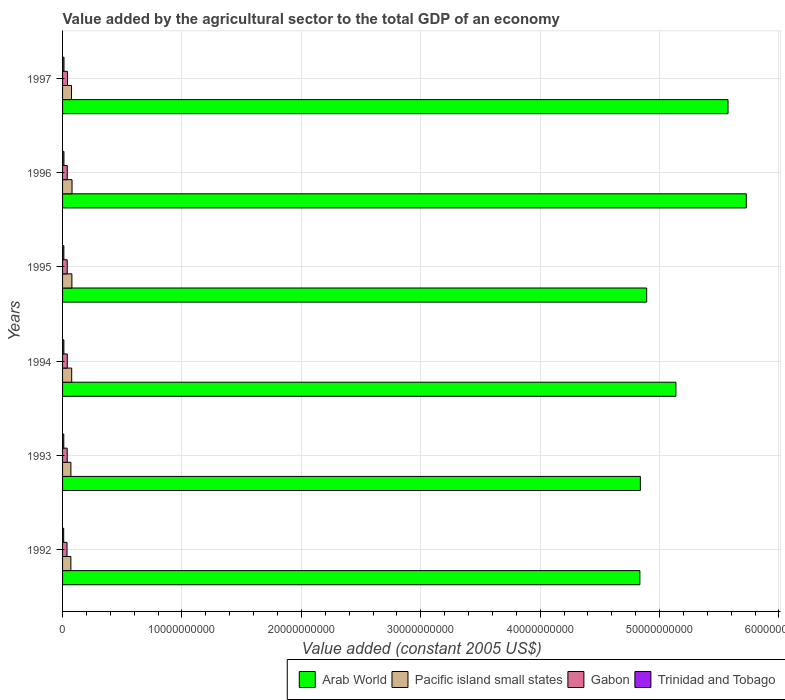How many different coloured bars are there?
Your answer should be very brief. 4. Are the number of bars on each tick of the Y-axis equal?
Keep it short and to the point. Yes. How many bars are there on the 3rd tick from the top?
Provide a succinct answer. 4. How many bars are there on the 3rd tick from the bottom?
Provide a short and direct response. 4. What is the value added by the agricultural sector in Trinidad and Tobago in 1997?
Provide a short and direct response. 1.20e+08. Across all years, what is the maximum value added by the agricultural sector in Arab World?
Keep it short and to the point. 5.73e+1. Across all years, what is the minimum value added by the agricultural sector in Trinidad and Tobago?
Offer a terse response. 9.41e+07. In which year was the value added by the agricultural sector in Pacific island small states maximum?
Your response must be concise. 1996. In which year was the value added by the agricultural sector in Trinidad and Tobago minimum?
Keep it short and to the point. 1992. What is the total value added by the agricultural sector in Pacific island small states in the graph?
Keep it short and to the point. 4.48e+09. What is the difference between the value added by the agricultural sector in Arab World in 1992 and that in 1994?
Your answer should be compact. -3.02e+09. What is the difference between the value added by the agricultural sector in Trinidad and Tobago in 1992 and the value added by the agricultural sector in Arab World in 1994?
Provide a succinct answer. -5.13e+1. What is the average value added by the agricultural sector in Arab World per year?
Provide a short and direct response. 5.17e+1. In the year 1996, what is the difference between the value added by the agricultural sector in Gabon and value added by the agricultural sector in Arab World?
Keep it short and to the point. -5.69e+1. What is the ratio of the value added by the agricultural sector in Gabon in 1992 to that in 1994?
Offer a very short reply. 0.94. Is the difference between the value added by the agricultural sector in Gabon in 1993 and 1996 greater than the difference between the value added by the agricultural sector in Arab World in 1993 and 1996?
Provide a short and direct response. Yes. What is the difference between the highest and the second highest value added by the agricultural sector in Gabon?
Your answer should be compact. 1.54e+07. What is the difference between the highest and the lowest value added by the agricultural sector in Gabon?
Ensure brevity in your answer.  3.72e+07. Is the sum of the value added by the agricultural sector in Trinidad and Tobago in 1994 and 1996 greater than the maximum value added by the agricultural sector in Arab World across all years?
Keep it short and to the point. No. Is it the case that in every year, the sum of the value added by the agricultural sector in Pacific island small states and value added by the agricultural sector in Trinidad and Tobago is greater than the sum of value added by the agricultural sector in Gabon and value added by the agricultural sector in Arab World?
Make the answer very short. No. What does the 2nd bar from the top in 1995 represents?
Your answer should be very brief. Gabon. What does the 3rd bar from the bottom in 1995 represents?
Offer a very short reply. Gabon. What is the difference between two consecutive major ticks on the X-axis?
Provide a succinct answer. 1.00e+1. Does the graph contain any zero values?
Your answer should be very brief. No. How many legend labels are there?
Provide a succinct answer. 4. What is the title of the graph?
Keep it short and to the point. Value added by the agricultural sector to the total GDP of an economy. Does "Korea (Republic)" appear as one of the legend labels in the graph?
Offer a terse response. No. What is the label or title of the X-axis?
Offer a terse response. Value added (constant 2005 US$). What is the Value added (constant 2005 US$) in Arab World in 1992?
Keep it short and to the point. 4.84e+1. What is the Value added (constant 2005 US$) of Pacific island small states in 1992?
Provide a short and direct response. 6.95e+08. What is the Value added (constant 2005 US$) in Gabon in 1992?
Provide a short and direct response. 3.73e+08. What is the Value added (constant 2005 US$) in Trinidad and Tobago in 1992?
Provide a succinct answer. 9.41e+07. What is the Value added (constant 2005 US$) of Arab World in 1993?
Provide a short and direct response. 4.84e+1. What is the Value added (constant 2005 US$) in Pacific island small states in 1993?
Your response must be concise. 6.99e+08. What is the Value added (constant 2005 US$) in Gabon in 1993?
Your answer should be compact. 3.89e+08. What is the Value added (constant 2005 US$) in Trinidad and Tobago in 1993?
Your response must be concise. 1.02e+08. What is the Value added (constant 2005 US$) of Arab World in 1994?
Your answer should be compact. 5.14e+1. What is the Value added (constant 2005 US$) of Pacific island small states in 1994?
Offer a terse response. 7.65e+08. What is the Value added (constant 2005 US$) of Gabon in 1994?
Give a very brief answer. 3.95e+08. What is the Value added (constant 2005 US$) in Trinidad and Tobago in 1994?
Your answer should be compact. 1.10e+08. What is the Value added (constant 2005 US$) of Arab World in 1995?
Keep it short and to the point. 4.89e+1. What is the Value added (constant 2005 US$) in Pacific island small states in 1995?
Keep it short and to the point. 7.81e+08. What is the Value added (constant 2005 US$) of Gabon in 1995?
Offer a very short reply. 3.90e+08. What is the Value added (constant 2005 US$) of Trinidad and Tobago in 1995?
Offer a terse response. 1.08e+08. What is the Value added (constant 2005 US$) in Arab World in 1996?
Ensure brevity in your answer.  5.73e+1. What is the Value added (constant 2005 US$) in Pacific island small states in 1996?
Ensure brevity in your answer.  7.92e+08. What is the Value added (constant 2005 US$) in Gabon in 1996?
Give a very brief answer. 3.93e+08. What is the Value added (constant 2005 US$) in Trinidad and Tobago in 1996?
Provide a short and direct response. 1.17e+08. What is the Value added (constant 2005 US$) in Arab World in 1997?
Offer a very short reply. 5.57e+1. What is the Value added (constant 2005 US$) of Pacific island small states in 1997?
Provide a short and direct response. 7.49e+08. What is the Value added (constant 2005 US$) in Gabon in 1997?
Your response must be concise. 4.10e+08. What is the Value added (constant 2005 US$) in Trinidad and Tobago in 1997?
Keep it short and to the point. 1.20e+08. Across all years, what is the maximum Value added (constant 2005 US$) of Arab World?
Your response must be concise. 5.73e+1. Across all years, what is the maximum Value added (constant 2005 US$) in Pacific island small states?
Provide a succinct answer. 7.92e+08. Across all years, what is the maximum Value added (constant 2005 US$) of Gabon?
Make the answer very short. 4.10e+08. Across all years, what is the maximum Value added (constant 2005 US$) of Trinidad and Tobago?
Your answer should be very brief. 1.20e+08. Across all years, what is the minimum Value added (constant 2005 US$) in Arab World?
Make the answer very short. 4.84e+1. Across all years, what is the minimum Value added (constant 2005 US$) in Pacific island small states?
Provide a succinct answer. 6.95e+08. Across all years, what is the minimum Value added (constant 2005 US$) in Gabon?
Provide a succinct answer. 3.73e+08. Across all years, what is the minimum Value added (constant 2005 US$) of Trinidad and Tobago?
Offer a very short reply. 9.41e+07. What is the total Value added (constant 2005 US$) of Arab World in the graph?
Provide a short and direct response. 3.10e+11. What is the total Value added (constant 2005 US$) of Pacific island small states in the graph?
Provide a succinct answer. 4.48e+09. What is the total Value added (constant 2005 US$) of Gabon in the graph?
Your answer should be very brief. 2.35e+09. What is the total Value added (constant 2005 US$) of Trinidad and Tobago in the graph?
Make the answer very short. 6.51e+08. What is the difference between the Value added (constant 2005 US$) of Arab World in 1992 and that in 1993?
Your response must be concise. -4.10e+07. What is the difference between the Value added (constant 2005 US$) in Pacific island small states in 1992 and that in 1993?
Ensure brevity in your answer.  -3.62e+06. What is the difference between the Value added (constant 2005 US$) of Gabon in 1992 and that in 1993?
Make the answer very short. -1.60e+07. What is the difference between the Value added (constant 2005 US$) in Trinidad and Tobago in 1992 and that in 1993?
Offer a terse response. -7.92e+06. What is the difference between the Value added (constant 2005 US$) in Arab World in 1992 and that in 1994?
Provide a short and direct response. -3.02e+09. What is the difference between the Value added (constant 2005 US$) in Pacific island small states in 1992 and that in 1994?
Make the answer very short. -6.95e+07. What is the difference between the Value added (constant 2005 US$) in Gabon in 1992 and that in 1994?
Your answer should be compact. -2.18e+07. What is the difference between the Value added (constant 2005 US$) of Trinidad and Tobago in 1992 and that in 1994?
Offer a terse response. -1.58e+07. What is the difference between the Value added (constant 2005 US$) in Arab World in 1992 and that in 1995?
Offer a terse response. -5.71e+08. What is the difference between the Value added (constant 2005 US$) of Pacific island small states in 1992 and that in 1995?
Offer a very short reply. -8.57e+07. What is the difference between the Value added (constant 2005 US$) of Gabon in 1992 and that in 1995?
Offer a very short reply. -1.66e+07. What is the difference between the Value added (constant 2005 US$) of Trinidad and Tobago in 1992 and that in 1995?
Provide a succinct answer. -1.44e+07. What is the difference between the Value added (constant 2005 US$) in Arab World in 1992 and that in 1996?
Ensure brevity in your answer.  -8.91e+09. What is the difference between the Value added (constant 2005 US$) of Pacific island small states in 1992 and that in 1996?
Your answer should be compact. -9.69e+07. What is the difference between the Value added (constant 2005 US$) in Gabon in 1992 and that in 1996?
Offer a terse response. -2.03e+07. What is the difference between the Value added (constant 2005 US$) in Trinidad and Tobago in 1992 and that in 1996?
Your response must be concise. -2.25e+07. What is the difference between the Value added (constant 2005 US$) in Arab World in 1992 and that in 1997?
Your answer should be compact. -7.38e+09. What is the difference between the Value added (constant 2005 US$) in Pacific island small states in 1992 and that in 1997?
Make the answer very short. -5.40e+07. What is the difference between the Value added (constant 2005 US$) in Gabon in 1992 and that in 1997?
Your answer should be compact. -3.72e+07. What is the difference between the Value added (constant 2005 US$) in Trinidad and Tobago in 1992 and that in 1997?
Make the answer very short. -2.61e+07. What is the difference between the Value added (constant 2005 US$) in Arab World in 1993 and that in 1994?
Provide a short and direct response. -2.98e+09. What is the difference between the Value added (constant 2005 US$) in Pacific island small states in 1993 and that in 1994?
Offer a terse response. -6.59e+07. What is the difference between the Value added (constant 2005 US$) of Gabon in 1993 and that in 1994?
Keep it short and to the point. -5.75e+06. What is the difference between the Value added (constant 2005 US$) in Trinidad and Tobago in 1993 and that in 1994?
Provide a short and direct response. -7.84e+06. What is the difference between the Value added (constant 2005 US$) of Arab World in 1993 and that in 1995?
Offer a terse response. -5.30e+08. What is the difference between the Value added (constant 2005 US$) of Pacific island small states in 1993 and that in 1995?
Offer a terse response. -8.21e+07. What is the difference between the Value added (constant 2005 US$) in Gabon in 1993 and that in 1995?
Offer a very short reply. -6.05e+05. What is the difference between the Value added (constant 2005 US$) in Trinidad and Tobago in 1993 and that in 1995?
Your answer should be very brief. -6.44e+06. What is the difference between the Value added (constant 2005 US$) of Arab World in 1993 and that in 1996?
Provide a short and direct response. -8.87e+09. What is the difference between the Value added (constant 2005 US$) of Pacific island small states in 1993 and that in 1996?
Your answer should be very brief. -9.33e+07. What is the difference between the Value added (constant 2005 US$) in Gabon in 1993 and that in 1996?
Your answer should be very brief. -4.24e+06. What is the difference between the Value added (constant 2005 US$) in Trinidad and Tobago in 1993 and that in 1996?
Ensure brevity in your answer.  -1.46e+07. What is the difference between the Value added (constant 2005 US$) of Arab World in 1993 and that in 1997?
Your answer should be very brief. -7.34e+09. What is the difference between the Value added (constant 2005 US$) in Pacific island small states in 1993 and that in 1997?
Offer a terse response. -5.04e+07. What is the difference between the Value added (constant 2005 US$) in Gabon in 1993 and that in 1997?
Offer a terse response. -2.12e+07. What is the difference between the Value added (constant 2005 US$) in Trinidad and Tobago in 1993 and that in 1997?
Keep it short and to the point. -1.82e+07. What is the difference between the Value added (constant 2005 US$) of Arab World in 1994 and that in 1995?
Provide a succinct answer. 2.45e+09. What is the difference between the Value added (constant 2005 US$) in Pacific island small states in 1994 and that in 1995?
Your answer should be very brief. -1.62e+07. What is the difference between the Value added (constant 2005 US$) of Gabon in 1994 and that in 1995?
Provide a succinct answer. 5.15e+06. What is the difference between the Value added (constant 2005 US$) of Trinidad and Tobago in 1994 and that in 1995?
Offer a very short reply. 1.41e+06. What is the difference between the Value added (constant 2005 US$) of Arab World in 1994 and that in 1996?
Your answer should be very brief. -5.89e+09. What is the difference between the Value added (constant 2005 US$) of Pacific island small states in 1994 and that in 1996?
Make the answer very short. -2.74e+07. What is the difference between the Value added (constant 2005 US$) in Gabon in 1994 and that in 1996?
Keep it short and to the point. 1.51e+06. What is the difference between the Value added (constant 2005 US$) in Trinidad and Tobago in 1994 and that in 1996?
Your response must be concise. -6.77e+06. What is the difference between the Value added (constant 2005 US$) of Arab World in 1994 and that in 1997?
Ensure brevity in your answer.  -4.36e+09. What is the difference between the Value added (constant 2005 US$) of Pacific island small states in 1994 and that in 1997?
Your response must be concise. 1.55e+07. What is the difference between the Value added (constant 2005 US$) in Gabon in 1994 and that in 1997?
Give a very brief answer. -1.54e+07. What is the difference between the Value added (constant 2005 US$) in Trinidad and Tobago in 1994 and that in 1997?
Offer a very short reply. -1.04e+07. What is the difference between the Value added (constant 2005 US$) of Arab World in 1995 and that in 1996?
Keep it short and to the point. -8.34e+09. What is the difference between the Value added (constant 2005 US$) in Pacific island small states in 1995 and that in 1996?
Offer a terse response. -1.12e+07. What is the difference between the Value added (constant 2005 US$) of Gabon in 1995 and that in 1996?
Keep it short and to the point. -3.63e+06. What is the difference between the Value added (constant 2005 US$) in Trinidad and Tobago in 1995 and that in 1996?
Your answer should be compact. -8.18e+06. What is the difference between the Value added (constant 2005 US$) in Arab World in 1995 and that in 1997?
Provide a short and direct response. -6.81e+09. What is the difference between the Value added (constant 2005 US$) in Pacific island small states in 1995 and that in 1997?
Make the answer very short. 3.17e+07. What is the difference between the Value added (constant 2005 US$) in Gabon in 1995 and that in 1997?
Offer a terse response. -2.06e+07. What is the difference between the Value added (constant 2005 US$) in Trinidad and Tobago in 1995 and that in 1997?
Your response must be concise. -1.18e+07. What is the difference between the Value added (constant 2005 US$) in Arab World in 1996 and that in 1997?
Make the answer very short. 1.53e+09. What is the difference between the Value added (constant 2005 US$) in Pacific island small states in 1996 and that in 1997?
Offer a terse response. 4.29e+07. What is the difference between the Value added (constant 2005 US$) of Gabon in 1996 and that in 1997?
Ensure brevity in your answer.  -1.69e+07. What is the difference between the Value added (constant 2005 US$) of Trinidad and Tobago in 1996 and that in 1997?
Your answer should be compact. -3.61e+06. What is the difference between the Value added (constant 2005 US$) of Arab World in 1992 and the Value added (constant 2005 US$) of Pacific island small states in 1993?
Give a very brief answer. 4.77e+1. What is the difference between the Value added (constant 2005 US$) of Arab World in 1992 and the Value added (constant 2005 US$) of Gabon in 1993?
Provide a succinct answer. 4.80e+1. What is the difference between the Value added (constant 2005 US$) of Arab World in 1992 and the Value added (constant 2005 US$) of Trinidad and Tobago in 1993?
Ensure brevity in your answer.  4.82e+1. What is the difference between the Value added (constant 2005 US$) of Pacific island small states in 1992 and the Value added (constant 2005 US$) of Gabon in 1993?
Keep it short and to the point. 3.07e+08. What is the difference between the Value added (constant 2005 US$) of Pacific island small states in 1992 and the Value added (constant 2005 US$) of Trinidad and Tobago in 1993?
Offer a very short reply. 5.93e+08. What is the difference between the Value added (constant 2005 US$) in Gabon in 1992 and the Value added (constant 2005 US$) in Trinidad and Tobago in 1993?
Ensure brevity in your answer.  2.71e+08. What is the difference between the Value added (constant 2005 US$) of Arab World in 1992 and the Value added (constant 2005 US$) of Pacific island small states in 1994?
Offer a terse response. 4.76e+1. What is the difference between the Value added (constant 2005 US$) of Arab World in 1992 and the Value added (constant 2005 US$) of Gabon in 1994?
Your answer should be very brief. 4.80e+1. What is the difference between the Value added (constant 2005 US$) in Arab World in 1992 and the Value added (constant 2005 US$) in Trinidad and Tobago in 1994?
Your response must be concise. 4.82e+1. What is the difference between the Value added (constant 2005 US$) in Pacific island small states in 1992 and the Value added (constant 2005 US$) in Gabon in 1994?
Your response must be concise. 3.01e+08. What is the difference between the Value added (constant 2005 US$) of Pacific island small states in 1992 and the Value added (constant 2005 US$) of Trinidad and Tobago in 1994?
Offer a very short reply. 5.86e+08. What is the difference between the Value added (constant 2005 US$) of Gabon in 1992 and the Value added (constant 2005 US$) of Trinidad and Tobago in 1994?
Offer a terse response. 2.63e+08. What is the difference between the Value added (constant 2005 US$) in Arab World in 1992 and the Value added (constant 2005 US$) in Pacific island small states in 1995?
Offer a very short reply. 4.76e+1. What is the difference between the Value added (constant 2005 US$) of Arab World in 1992 and the Value added (constant 2005 US$) of Gabon in 1995?
Offer a terse response. 4.80e+1. What is the difference between the Value added (constant 2005 US$) of Arab World in 1992 and the Value added (constant 2005 US$) of Trinidad and Tobago in 1995?
Ensure brevity in your answer.  4.82e+1. What is the difference between the Value added (constant 2005 US$) of Pacific island small states in 1992 and the Value added (constant 2005 US$) of Gabon in 1995?
Make the answer very short. 3.06e+08. What is the difference between the Value added (constant 2005 US$) of Pacific island small states in 1992 and the Value added (constant 2005 US$) of Trinidad and Tobago in 1995?
Your response must be concise. 5.87e+08. What is the difference between the Value added (constant 2005 US$) of Gabon in 1992 and the Value added (constant 2005 US$) of Trinidad and Tobago in 1995?
Provide a short and direct response. 2.64e+08. What is the difference between the Value added (constant 2005 US$) of Arab World in 1992 and the Value added (constant 2005 US$) of Pacific island small states in 1996?
Your response must be concise. 4.76e+1. What is the difference between the Value added (constant 2005 US$) in Arab World in 1992 and the Value added (constant 2005 US$) in Gabon in 1996?
Ensure brevity in your answer.  4.80e+1. What is the difference between the Value added (constant 2005 US$) in Arab World in 1992 and the Value added (constant 2005 US$) in Trinidad and Tobago in 1996?
Your answer should be compact. 4.82e+1. What is the difference between the Value added (constant 2005 US$) in Pacific island small states in 1992 and the Value added (constant 2005 US$) in Gabon in 1996?
Your response must be concise. 3.02e+08. What is the difference between the Value added (constant 2005 US$) of Pacific island small states in 1992 and the Value added (constant 2005 US$) of Trinidad and Tobago in 1996?
Provide a short and direct response. 5.79e+08. What is the difference between the Value added (constant 2005 US$) in Gabon in 1992 and the Value added (constant 2005 US$) in Trinidad and Tobago in 1996?
Offer a very short reply. 2.56e+08. What is the difference between the Value added (constant 2005 US$) in Arab World in 1992 and the Value added (constant 2005 US$) in Pacific island small states in 1997?
Offer a very short reply. 4.76e+1. What is the difference between the Value added (constant 2005 US$) of Arab World in 1992 and the Value added (constant 2005 US$) of Gabon in 1997?
Keep it short and to the point. 4.79e+1. What is the difference between the Value added (constant 2005 US$) in Arab World in 1992 and the Value added (constant 2005 US$) in Trinidad and Tobago in 1997?
Your answer should be very brief. 4.82e+1. What is the difference between the Value added (constant 2005 US$) in Pacific island small states in 1992 and the Value added (constant 2005 US$) in Gabon in 1997?
Provide a short and direct response. 2.85e+08. What is the difference between the Value added (constant 2005 US$) of Pacific island small states in 1992 and the Value added (constant 2005 US$) of Trinidad and Tobago in 1997?
Provide a short and direct response. 5.75e+08. What is the difference between the Value added (constant 2005 US$) of Gabon in 1992 and the Value added (constant 2005 US$) of Trinidad and Tobago in 1997?
Your answer should be very brief. 2.53e+08. What is the difference between the Value added (constant 2005 US$) in Arab World in 1993 and the Value added (constant 2005 US$) in Pacific island small states in 1994?
Give a very brief answer. 4.76e+1. What is the difference between the Value added (constant 2005 US$) in Arab World in 1993 and the Value added (constant 2005 US$) in Gabon in 1994?
Offer a terse response. 4.80e+1. What is the difference between the Value added (constant 2005 US$) of Arab World in 1993 and the Value added (constant 2005 US$) of Trinidad and Tobago in 1994?
Offer a terse response. 4.83e+1. What is the difference between the Value added (constant 2005 US$) in Pacific island small states in 1993 and the Value added (constant 2005 US$) in Gabon in 1994?
Ensure brevity in your answer.  3.04e+08. What is the difference between the Value added (constant 2005 US$) of Pacific island small states in 1993 and the Value added (constant 2005 US$) of Trinidad and Tobago in 1994?
Offer a terse response. 5.89e+08. What is the difference between the Value added (constant 2005 US$) in Gabon in 1993 and the Value added (constant 2005 US$) in Trinidad and Tobago in 1994?
Ensure brevity in your answer.  2.79e+08. What is the difference between the Value added (constant 2005 US$) of Arab World in 1993 and the Value added (constant 2005 US$) of Pacific island small states in 1995?
Make the answer very short. 4.76e+1. What is the difference between the Value added (constant 2005 US$) in Arab World in 1993 and the Value added (constant 2005 US$) in Gabon in 1995?
Make the answer very short. 4.80e+1. What is the difference between the Value added (constant 2005 US$) in Arab World in 1993 and the Value added (constant 2005 US$) in Trinidad and Tobago in 1995?
Your response must be concise. 4.83e+1. What is the difference between the Value added (constant 2005 US$) of Pacific island small states in 1993 and the Value added (constant 2005 US$) of Gabon in 1995?
Offer a very short reply. 3.10e+08. What is the difference between the Value added (constant 2005 US$) in Pacific island small states in 1993 and the Value added (constant 2005 US$) in Trinidad and Tobago in 1995?
Provide a short and direct response. 5.91e+08. What is the difference between the Value added (constant 2005 US$) in Gabon in 1993 and the Value added (constant 2005 US$) in Trinidad and Tobago in 1995?
Offer a terse response. 2.80e+08. What is the difference between the Value added (constant 2005 US$) of Arab World in 1993 and the Value added (constant 2005 US$) of Pacific island small states in 1996?
Your answer should be compact. 4.76e+1. What is the difference between the Value added (constant 2005 US$) of Arab World in 1993 and the Value added (constant 2005 US$) of Gabon in 1996?
Your answer should be very brief. 4.80e+1. What is the difference between the Value added (constant 2005 US$) in Arab World in 1993 and the Value added (constant 2005 US$) in Trinidad and Tobago in 1996?
Your answer should be very brief. 4.83e+1. What is the difference between the Value added (constant 2005 US$) in Pacific island small states in 1993 and the Value added (constant 2005 US$) in Gabon in 1996?
Your answer should be compact. 3.06e+08. What is the difference between the Value added (constant 2005 US$) in Pacific island small states in 1993 and the Value added (constant 2005 US$) in Trinidad and Tobago in 1996?
Provide a short and direct response. 5.82e+08. What is the difference between the Value added (constant 2005 US$) of Gabon in 1993 and the Value added (constant 2005 US$) of Trinidad and Tobago in 1996?
Your answer should be compact. 2.72e+08. What is the difference between the Value added (constant 2005 US$) of Arab World in 1993 and the Value added (constant 2005 US$) of Pacific island small states in 1997?
Provide a succinct answer. 4.76e+1. What is the difference between the Value added (constant 2005 US$) of Arab World in 1993 and the Value added (constant 2005 US$) of Gabon in 1997?
Your response must be concise. 4.80e+1. What is the difference between the Value added (constant 2005 US$) of Arab World in 1993 and the Value added (constant 2005 US$) of Trinidad and Tobago in 1997?
Ensure brevity in your answer.  4.83e+1. What is the difference between the Value added (constant 2005 US$) in Pacific island small states in 1993 and the Value added (constant 2005 US$) in Gabon in 1997?
Make the answer very short. 2.89e+08. What is the difference between the Value added (constant 2005 US$) of Pacific island small states in 1993 and the Value added (constant 2005 US$) of Trinidad and Tobago in 1997?
Make the answer very short. 5.79e+08. What is the difference between the Value added (constant 2005 US$) in Gabon in 1993 and the Value added (constant 2005 US$) in Trinidad and Tobago in 1997?
Give a very brief answer. 2.69e+08. What is the difference between the Value added (constant 2005 US$) in Arab World in 1994 and the Value added (constant 2005 US$) in Pacific island small states in 1995?
Provide a succinct answer. 5.06e+1. What is the difference between the Value added (constant 2005 US$) of Arab World in 1994 and the Value added (constant 2005 US$) of Gabon in 1995?
Your response must be concise. 5.10e+1. What is the difference between the Value added (constant 2005 US$) of Arab World in 1994 and the Value added (constant 2005 US$) of Trinidad and Tobago in 1995?
Provide a succinct answer. 5.13e+1. What is the difference between the Value added (constant 2005 US$) of Pacific island small states in 1994 and the Value added (constant 2005 US$) of Gabon in 1995?
Ensure brevity in your answer.  3.75e+08. What is the difference between the Value added (constant 2005 US$) in Pacific island small states in 1994 and the Value added (constant 2005 US$) in Trinidad and Tobago in 1995?
Your answer should be very brief. 6.56e+08. What is the difference between the Value added (constant 2005 US$) in Gabon in 1994 and the Value added (constant 2005 US$) in Trinidad and Tobago in 1995?
Your response must be concise. 2.86e+08. What is the difference between the Value added (constant 2005 US$) of Arab World in 1994 and the Value added (constant 2005 US$) of Pacific island small states in 1996?
Your response must be concise. 5.06e+1. What is the difference between the Value added (constant 2005 US$) of Arab World in 1994 and the Value added (constant 2005 US$) of Gabon in 1996?
Ensure brevity in your answer.  5.10e+1. What is the difference between the Value added (constant 2005 US$) in Arab World in 1994 and the Value added (constant 2005 US$) in Trinidad and Tobago in 1996?
Your response must be concise. 5.13e+1. What is the difference between the Value added (constant 2005 US$) of Pacific island small states in 1994 and the Value added (constant 2005 US$) of Gabon in 1996?
Provide a short and direct response. 3.72e+08. What is the difference between the Value added (constant 2005 US$) of Pacific island small states in 1994 and the Value added (constant 2005 US$) of Trinidad and Tobago in 1996?
Keep it short and to the point. 6.48e+08. What is the difference between the Value added (constant 2005 US$) in Gabon in 1994 and the Value added (constant 2005 US$) in Trinidad and Tobago in 1996?
Your answer should be very brief. 2.78e+08. What is the difference between the Value added (constant 2005 US$) in Arab World in 1994 and the Value added (constant 2005 US$) in Pacific island small states in 1997?
Provide a short and direct response. 5.06e+1. What is the difference between the Value added (constant 2005 US$) in Arab World in 1994 and the Value added (constant 2005 US$) in Gabon in 1997?
Your response must be concise. 5.10e+1. What is the difference between the Value added (constant 2005 US$) in Arab World in 1994 and the Value added (constant 2005 US$) in Trinidad and Tobago in 1997?
Your answer should be compact. 5.12e+1. What is the difference between the Value added (constant 2005 US$) of Pacific island small states in 1994 and the Value added (constant 2005 US$) of Gabon in 1997?
Offer a terse response. 3.55e+08. What is the difference between the Value added (constant 2005 US$) in Pacific island small states in 1994 and the Value added (constant 2005 US$) in Trinidad and Tobago in 1997?
Make the answer very short. 6.45e+08. What is the difference between the Value added (constant 2005 US$) in Gabon in 1994 and the Value added (constant 2005 US$) in Trinidad and Tobago in 1997?
Your answer should be compact. 2.74e+08. What is the difference between the Value added (constant 2005 US$) of Arab World in 1995 and the Value added (constant 2005 US$) of Pacific island small states in 1996?
Give a very brief answer. 4.81e+1. What is the difference between the Value added (constant 2005 US$) in Arab World in 1995 and the Value added (constant 2005 US$) in Gabon in 1996?
Give a very brief answer. 4.85e+1. What is the difference between the Value added (constant 2005 US$) of Arab World in 1995 and the Value added (constant 2005 US$) of Trinidad and Tobago in 1996?
Ensure brevity in your answer.  4.88e+1. What is the difference between the Value added (constant 2005 US$) in Pacific island small states in 1995 and the Value added (constant 2005 US$) in Gabon in 1996?
Provide a short and direct response. 3.88e+08. What is the difference between the Value added (constant 2005 US$) in Pacific island small states in 1995 and the Value added (constant 2005 US$) in Trinidad and Tobago in 1996?
Your answer should be very brief. 6.65e+08. What is the difference between the Value added (constant 2005 US$) of Gabon in 1995 and the Value added (constant 2005 US$) of Trinidad and Tobago in 1996?
Make the answer very short. 2.73e+08. What is the difference between the Value added (constant 2005 US$) of Arab World in 1995 and the Value added (constant 2005 US$) of Pacific island small states in 1997?
Make the answer very short. 4.82e+1. What is the difference between the Value added (constant 2005 US$) in Arab World in 1995 and the Value added (constant 2005 US$) in Gabon in 1997?
Give a very brief answer. 4.85e+1. What is the difference between the Value added (constant 2005 US$) in Arab World in 1995 and the Value added (constant 2005 US$) in Trinidad and Tobago in 1997?
Your answer should be compact. 4.88e+1. What is the difference between the Value added (constant 2005 US$) of Pacific island small states in 1995 and the Value added (constant 2005 US$) of Gabon in 1997?
Offer a terse response. 3.71e+08. What is the difference between the Value added (constant 2005 US$) in Pacific island small states in 1995 and the Value added (constant 2005 US$) in Trinidad and Tobago in 1997?
Make the answer very short. 6.61e+08. What is the difference between the Value added (constant 2005 US$) in Gabon in 1995 and the Value added (constant 2005 US$) in Trinidad and Tobago in 1997?
Offer a very short reply. 2.69e+08. What is the difference between the Value added (constant 2005 US$) of Arab World in 1996 and the Value added (constant 2005 US$) of Pacific island small states in 1997?
Give a very brief answer. 5.65e+1. What is the difference between the Value added (constant 2005 US$) of Arab World in 1996 and the Value added (constant 2005 US$) of Gabon in 1997?
Provide a short and direct response. 5.69e+1. What is the difference between the Value added (constant 2005 US$) of Arab World in 1996 and the Value added (constant 2005 US$) of Trinidad and Tobago in 1997?
Provide a short and direct response. 5.71e+1. What is the difference between the Value added (constant 2005 US$) in Pacific island small states in 1996 and the Value added (constant 2005 US$) in Gabon in 1997?
Your response must be concise. 3.82e+08. What is the difference between the Value added (constant 2005 US$) of Pacific island small states in 1996 and the Value added (constant 2005 US$) of Trinidad and Tobago in 1997?
Keep it short and to the point. 6.72e+08. What is the difference between the Value added (constant 2005 US$) of Gabon in 1996 and the Value added (constant 2005 US$) of Trinidad and Tobago in 1997?
Ensure brevity in your answer.  2.73e+08. What is the average Value added (constant 2005 US$) in Arab World per year?
Ensure brevity in your answer.  5.17e+1. What is the average Value added (constant 2005 US$) of Pacific island small states per year?
Keep it short and to the point. 7.47e+08. What is the average Value added (constant 2005 US$) of Gabon per year?
Your answer should be very brief. 3.92e+08. What is the average Value added (constant 2005 US$) in Trinidad and Tobago per year?
Provide a short and direct response. 1.09e+08. In the year 1992, what is the difference between the Value added (constant 2005 US$) of Arab World and Value added (constant 2005 US$) of Pacific island small states?
Keep it short and to the point. 4.77e+1. In the year 1992, what is the difference between the Value added (constant 2005 US$) in Arab World and Value added (constant 2005 US$) in Gabon?
Your answer should be compact. 4.80e+1. In the year 1992, what is the difference between the Value added (constant 2005 US$) of Arab World and Value added (constant 2005 US$) of Trinidad and Tobago?
Your answer should be very brief. 4.83e+1. In the year 1992, what is the difference between the Value added (constant 2005 US$) of Pacific island small states and Value added (constant 2005 US$) of Gabon?
Provide a short and direct response. 3.23e+08. In the year 1992, what is the difference between the Value added (constant 2005 US$) of Pacific island small states and Value added (constant 2005 US$) of Trinidad and Tobago?
Your answer should be compact. 6.01e+08. In the year 1992, what is the difference between the Value added (constant 2005 US$) of Gabon and Value added (constant 2005 US$) of Trinidad and Tobago?
Your answer should be very brief. 2.79e+08. In the year 1993, what is the difference between the Value added (constant 2005 US$) of Arab World and Value added (constant 2005 US$) of Pacific island small states?
Offer a very short reply. 4.77e+1. In the year 1993, what is the difference between the Value added (constant 2005 US$) of Arab World and Value added (constant 2005 US$) of Gabon?
Ensure brevity in your answer.  4.80e+1. In the year 1993, what is the difference between the Value added (constant 2005 US$) in Arab World and Value added (constant 2005 US$) in Trinidad and Tobago?
Your answer should be compact. 4.83e+1. In the year 1993, what is the difference between the Value added (constant 2005 US$) of Pacific island small states and Value added (constant 2005 US$) of Gabon?
Provide a short and direct response. 3.10e+08. In the year 1993, what is the difference between the Value added (constant 2005 US$) of Pacific island small states and Value added (constant 2005 US$) of Trinidad and Tobago?
Provide a succinct answer. 5.97e+08. In the year 1993, what is the difference between the Value added (constant 2005 US$) of Gabon and Value added (constant 2005 US$) of Trinidad and Tobago?
Give a very brief answer. 2.87e+08. In the year 1994, what is the difference between the Value added (constant 2005 US$) in Arab World and Value added (constant 2005 US$) in Pacific island small states?
Ensure brevity in your answer.  5.06e+1. In the year 1994, what is the difference between the Value added (constant 2005 US$) of Arab World and Value added (constant 2005 US$) of Gabon?
Your answer should be very brief. 5.10e+1. In the year 1994, what is the difference between the Value added (constant 2005 US$) in Arab World and Value added (constant 2005 US$) in Trinidad and Tobago?
Offer a very short reply. 5.13e+1. In the year 1994, what is the difference between the Value added (constant 2005 US$) of Pacific island small states and Value added (constant 2005 US$) of Gabon?
Your answer should be compact. 3.70e+08. In the year 1994, what is the difference between the Value added (constant 2005 US$) in Pacific island small states and Value added (constant 2005 US$) in Trinidad and Tobago?
Offer a very short reply. 6.55e+08. In the year 1994, what is the difference between the Value added (constant 2005 US$) in Gabon and Value added (constant 2005 US$) in Trinidad and Tobago?
Provide a succinct answer. 2.85e+08. In the year 1995, what is the difference between the Value added (constant 2005 US$) of Arab World and Value added (constant 2005 US$) of Pacific island small states?
Your answer should be very brief. 4.81e+1. In the year 1995, what is the difference between the Value added (constant 2005 US$) of Arab World and Value added (constant 2005 US$) of Gabon?
Offer a very short reply. 4.85e+1. In the year 1995, what is the difference between the Value added (constant 2005 US$) of Arab World and Value added (constant 2005 US$) of Trinidad and Tobago?
Offer a terse response. 4.88e+1. In the year 1995, what is the difference between the Value added (constant 2005 US$) of Pacific island small states and Value added (constant 2005 US$) of Gabon?
Your response must be concise. 3.92e+08. In the year 1995, what is the difference between the Value added (constant 2005 US$) of Pacific island small states and Value added (constant 2005 US$) of Trinidad and Tobago?
Make the answer very short. 6.73e+08. In the year 1995, what is the difference between the Value added (constant 2005 US$) in Gabon and Value added (constant 2005 US$) in Trinidad and Tobago?
Make the answer very short. 2.81e+08. In the year 1996, what is the difference between the Value added (constant 2005 US$) of Arab World and Value added (constant 2005 US$) of Pacific island small states?
Offer a terse response. 5.65e+1. In the year 1996, what is the difference between the Value added (constant 2005 US$) in Arab World and Value added (constant 2005 US$) in Gabon?
Your answer should be compact. 5.69e+1. In the year 1996, what is the difference between the Value added (constant 2005 US$) of Arab World and Value added (constant 2005 US$) of Trinidad and Tobago?
Give a very brief answer. 5.71e+1. In the year 1996, what is the difference between the Value added (constant 2005 US$) of Pacific island small states and Value added (constant 2005 US$) of Gabon?
Offer a very short reply. 3.99e+08. In the year 1996, what is the difference between the Value added (constant 2005 US$) in Pacific island small states and Value added (constant 2005 US$) in Trinidad and Tobago?
Keep it short and to the point. 6.76e+08. In the year 1996, what is the difference between the Value added (constant 2005 US$) in Gabon and Value added (constant 2005 US$) in Trinidad and Tobago?
Provide a succinct answer. 2.77e+08. In the year 1997, what is the difference between the Value added (constant 2005 US$) of Arab World and Value added (constant 2005 US$) of Pacific island small states?
Provide a short and direct response. 5.50e+1. In the year 1997, what is the difference between the Value added (constant 2005 US$) in Arab World and Value added (constant 2005 US$) in Gabon?
Provide a short and direct response. 5.53e+1. In the year 1997, what is the difference between the Value added (constant 2005 US$) of Arab World and Value added (constant 2005 US$) of Trinidad and Tobago?
Your answer should be very brief. 5.56e+1. In the year 1997, what is the difference between the Value added (constant 2005 US$) in Pacific island small states and Value added (constant 2005 US$) in Gabon?
Offer a very short reply. 3.39e+08. In the year 1997, what is the difference between the Value added (constant 2005 US$) in Pacific island small states and Value added (constant 2005 US$) in Trinidad and Tobago?
Make the answer very short. 6.29e+08. In the year 1997, what is the difference between the Value added (constant 2005 US$) in Gabon and Value added (constant 2005 US$) in Trinidad and Tobago?
Provide a succinct answer. 2.90e+08. What is the ratio of the Value added (constant 2005 US$) in Arab World in 1992 to that in 1993?
Offer a terse response. 1. What is the ratio of the Value added (constant 2005 US$) of Gabon in 1992 to that in 1993?
Your response must be concise. 0.96. What is the ratio of the Value added (constant 2005 US$) of Trinidad and Tobago in 1992 to that in 1993?
Provide a short and direct response. 0.92. What is the ratio of the Value added (constant 2005 US$) of Gabon in 1992 to that in 1994?
Provide a short and direct response. 0.94. What is the ratio of the Value added (constant 2005 US$) of Trinidad and Tobago in 1992 to that in 1994?
Offer a terse response. 0.86. What is the ratio of the Value added (constant 2005 US$) in Arab World in 1992 to that in 1995?
Offer a terse response. 0.99. What is the ratio of the Value added (constant 2005 US$) of Pacific island small states in 1992 to that in 1995?
Offer a terse response. 0.89. What is the ratio of the Value added (constant 2005 US$) of Gabon in 1992 to that in 1995?
Ensure brevity in your answer.  0.96. What is the ratio of the Value added (constant 2005 US$) of Trinidad and Tobago in 1992 to that in 1995?
Keep it short and to the point. 0.87. What is the ratio of the Value added (constant 2005 US$) of Arab World in 1992 to that in 1996?
Give a very brief answer. 0.84. What is the ratio of the Value added (constant 2005 US$) in Pacific island small states in 1992 to that in 1996?
Your response must be concise. 0.88. What is the ratio of the Value added (constant 2005 US$) in Gabon in 1992 to that in 1996?
Your answer should be very brief. 0.95. What is the ratio of the Value added (constant 2005 US$) in Trinidad and Tobago in 1992 to that in 1996?
Provide a short and direct response. 0.81. What is the ratio of the Value added (constant 2005 US$) in Arab World in 1992 to that in 1997?
Keep it short and to the point. 0.87. What is the ratio of the Value added (constant 2005 US$) of Pacific island small states in 1992 to that in 1997?
Your answer should be very brief. 0.93. What is the ratio of the Value added (constant 2005 US$) of Gabon in 1992 to that in 1997?
Keep it short and to the point. 0.91. What is the ratio of the Value added (constant 2005 US$) in Trinidad and Tobago in 1992 to that in 1997?
Offer a terse response. 0.78. What is the ratio of the Value added (constant 2005 US$) of Arab World in 1993 to that in 1994?
Offer a terse response. 0.94. What is the ratio of the Value added (constant 2005 US$) of Pacific island small states in 1993 to that in 1994?
Offer a terse response. 0.91. What is the ratio of the Value added (constant 2005 US$) in Gabon in 1993 to that in 1994?
Keep it short and to the point. 0.99. What is the ratio of the Value added (constant 2005 US$) in Arab World in 1993 to that in 1995?
Your response must be concise. 0.99. What is the ratio of the Value added (constant 2005 US$) of Pacific island small states in 1993 to that in 1995?
Your answer should be compact. 0.89. What is the ratio of the Value added (constant 2005 US$) of Trinidad and Tobago in 1993 to that in 1995?
Keep it short and to the point. 0.94. What is the ratio of the Value added (constant 2005 US$) in Arab World in 1993 to that in 1996?
Give a very brief answer. 0.85. What is the ratio of the Value added (constant 2005 US$) in Pacific island small states in 1993 to that in 1996?
Your answer should be very brief. 0.88. What is the ratio of the Value added (constant 2005 US$) in Gabon in 1993 to that in 1996?
Ensure brevity in your answer.  0.99. What is the ratio of the Value added (constant 2005 US$) of Trinidad and Tobago in 1993 to that in 1996?
Your answer should be very brief. 0.87. What is the ratio of the Value added (constant 2005 US$) of Arab World in 1993 to that in 1997?
Provide a short and direct response. 0.87. What is the ratio of the Value added (constant 2005 US$) in Pacific island small states in 1993 to that in 1997?
Provide a succinct answer. 0.93. What is the ratio of the Value added (constant 2005 US$) of Gabon in 1993 to that in 1997?
Provide a succinct answer. 0.95. What is the ratio of the Value added (constant 2005 US$) in Trinidad and Tobago in 1993 to that in 1997?
Your answer should be very brief. 0.85. What is the ratio of the Value added (constant 2005 US$) in Arab World in 1994 to that in 1995?
Make the answer very short. 1.05. What is the ratio of the Value added (constant 2005 US$) in Pacific island small states in 1994 to that in 1995?
Offer a very short reply. 0.98. What is the ratio of the Value added (constant 2005 US$) of Gabon in 1994 to that in 1995?
Your answer should be very brief. 1.01. What is the ratio of the Value added (constant 2005 US$) in Arab World in 1994 to that in 1996?
Your answer should be compact. 0.9. What is the ratio of the Value added (constant 2005 US$) in Pacific island small states in 1994 to that in 1996?
Offer a terse response. 0.97. What is the ratio of the Value added (constant 2005 US$) of Gabon in 1994 to that in 1996?
Offer a terse response. 1. What is the ratio of the Value added (constant 2005 US$) in Trinidad and Tobago in 1994 to that in 1996?
Ensure brevity in your answer.  0.94. What is the ratio of the Value added (constant 2005 US$) of Arab World in 1994 to that in 1997?
Your response must be concise. 0.92. What is the ratio of the Value added (constant 2005 US$) of Pacific island small states in 1994 to that in 1997?
Give a very brief answer. 1.02. What is the ratio of the Value added (constant 2005 US$) in Gabon in 1994 to that in 1997?
Make the answer very short. 0.96. What is the ratio of the Value added (constant 2005 US$) in Trinidad and Tobago in 1994 to that in 1997?
Give a very brief answer. 0.91. What is the ratio of the Value added (constant 2005 US$) in Arab World in 1995 to that in 1996?
Offer a terse response. 0.85. What is the ratio of the Value added (constant 2005 US$) of Pacific island small states in 1995 to that in 1996?
Offer a terse response. 0.99. What is the ratio of the Value added (constant 2005 US$) of Gabon in 1995 to that in 1996?
Offer a terse response. 0.99. What is the ratio of the Value added (constant 2005 US$) in Trinidad and Tobago in 1995 to that in 1996?
Your answer should be very brief. 0.93. What is the ratio of the Value added (constant 2005 US$) of Arab World in 1995 to that in 1997?
Offer a very short reply. 0.88. What is the ratio of the Value added (constant 2005 US$) in Pacific island small states in 1995 to that in 1997?
Make the answer very short. 1.04. What is the ratio of the Value added (constant 2005 US$) of Gabon in 1995 to that in 1997?
Make the answer very short. 0.95. What is the ratio of the Value added (constant 2005 US$) of Trinidad and Tobago in 1995 to that in 1997?
Provide a short and direct response. 0.9. What is the ratio of the Value added (constant 2005 US$) of Arab World in 1996 to that in 1997?
Make the answer very short. 1.03. What is the ratio of the Value added (constant 2005 US$) in Pacific island small states in 1996 to that in 1997?
Offer a very short reply. 1.06. What is the ratio of the Value added (constant 2005 US$) of Gabon in 1996 to that in 1997?
Offer a very short reply. 0.96. What is the difference between the highest and the second highest Value added (constant 2005 US$) of Arab World?
Your answer should be compact. 1.53e+09. What is the difference between the highest and the second highest Value added (constant 2005 US$) of Pacific island small states?
Your answer should be compact. 1.12e+07. What is the difference between the highest and the second highest Value added (constant 2005 US$) in Gabon?
Your answer should be compact. 1.54e+07. What is the difference between the highest and the second highest Value added (constant 2005 US$) of Trinidad and Tobago?
Give a very brief answer. 3.61e+06. What is the difference between the highest and the lowest Value added (constant 2005 US$) of Arab World?
Provide a succinct answer. 8.91e+09. What is the difference between the highest and the lowest Value added (constant 2005 US$) of Pacific island small states?
Offer a very short reply. 9.69e+07. What is the difference between the highest and the lowest Value added (constant 2005 US$) in Gabon?
Make the answer very short. 3.72e+07. What is the difference between the highest and the lowest Value added (constant 2005 US$) of Trinidad and Tobago?
Provide a succinct answer. 2.61e+07. 